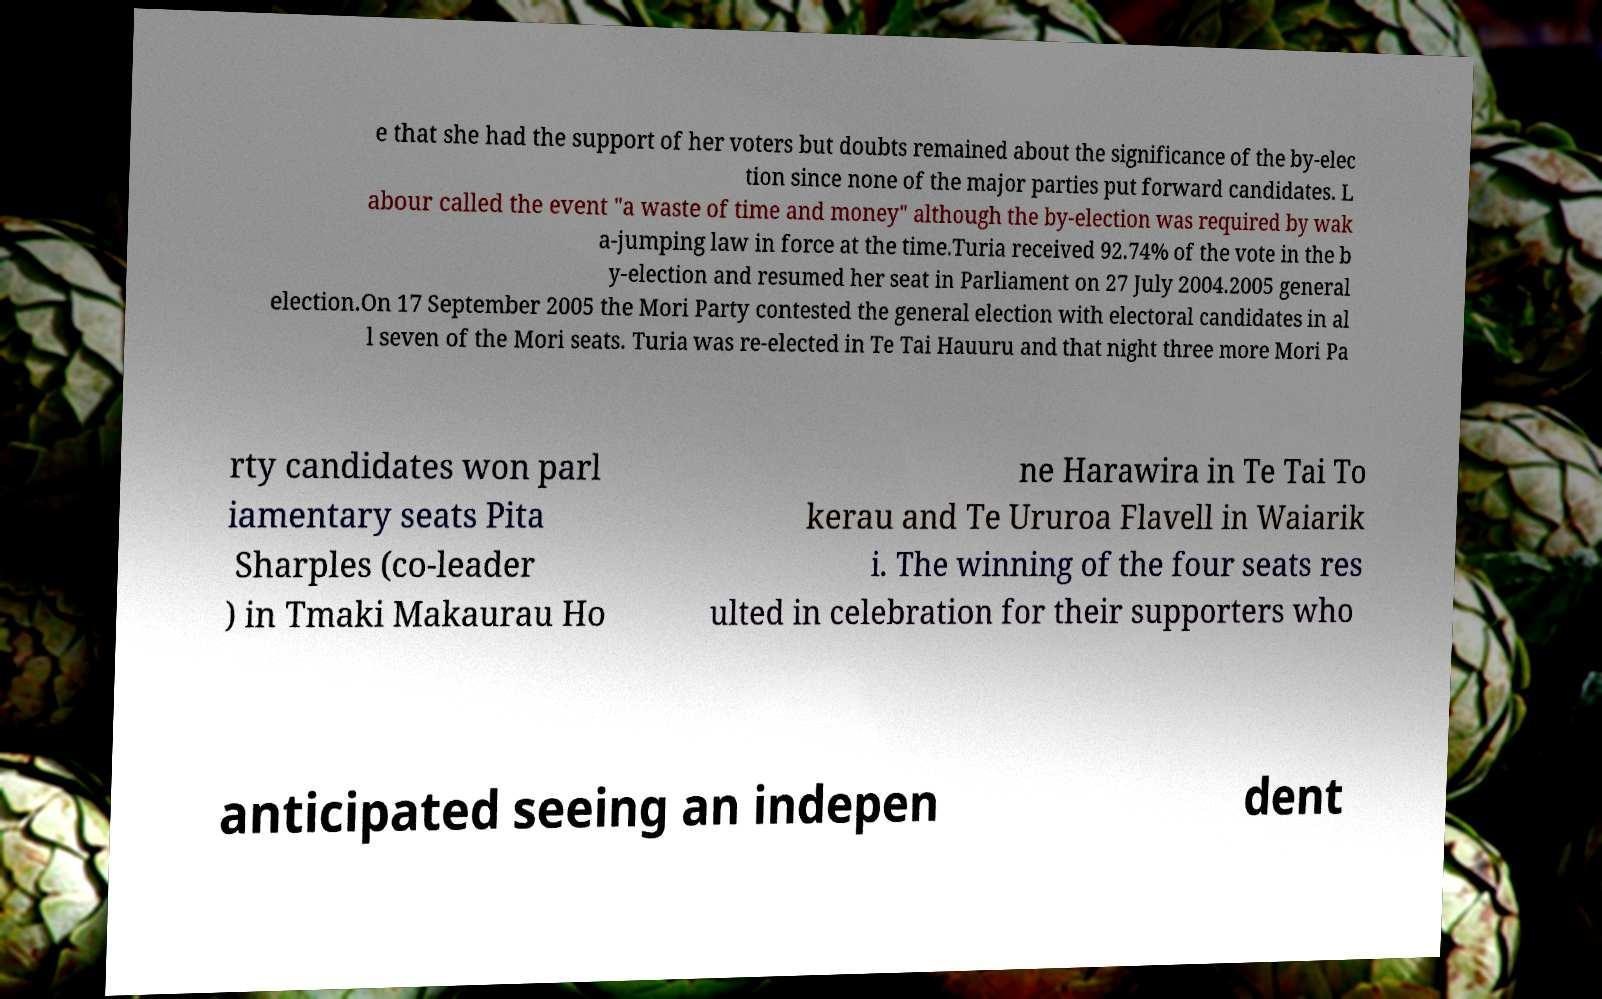For documentation purposes, I need the text within this image transcribed. Could you provide that? e that she had the support of her voters but doubts remained about the significance of the by-elec tion since none of the major parties put forward candidates. L abour called the event "a waste of time and money" although the by-election was required by wak a-jumping law in force at the time.Turia received 92.74% of the vote in the b y-election and resumed her seat in Parliament on 27 July 2004.2005 general election.On 17 September 2005 the Mori Party contested the general election with electoral candidates in al l seven of the Mori seats. Turia was re-elected in Te Tai Hauuru and that night three more Mori Pa rty candidates won parl iamentary seats Pita Sharples (co-leader ) in Tmaki Makaurau Ho ne Harawira in Te Tai To kerau and Te Ururoa Flavell in Waiarik i. The winning of the four seats res ulted in celebration for their supporters who anticipated seeing an indepen dent 